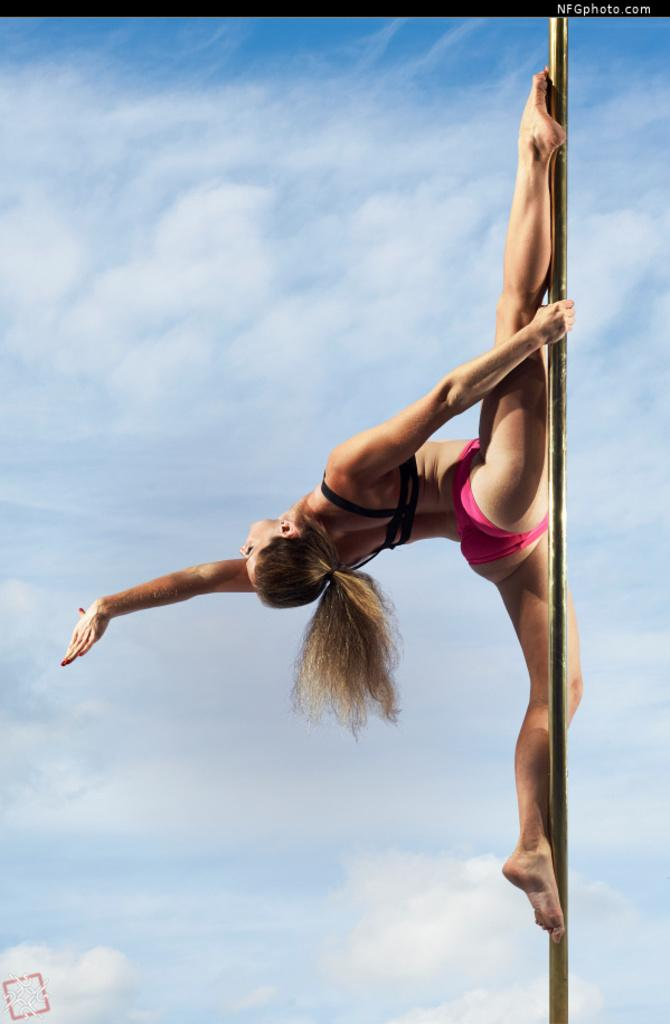What activity is the woman in the image performing? The woman is doing pole vault in the image. Is there any text present in the image? Yes, there is some text on the image. What can be seen in the background of the image? The sky is visible in the background of the image. How many beggars are visible in the image? There are no beggars present in the image. What color is the balloon being held by the woman in the image? There is no balloon present in the image. 